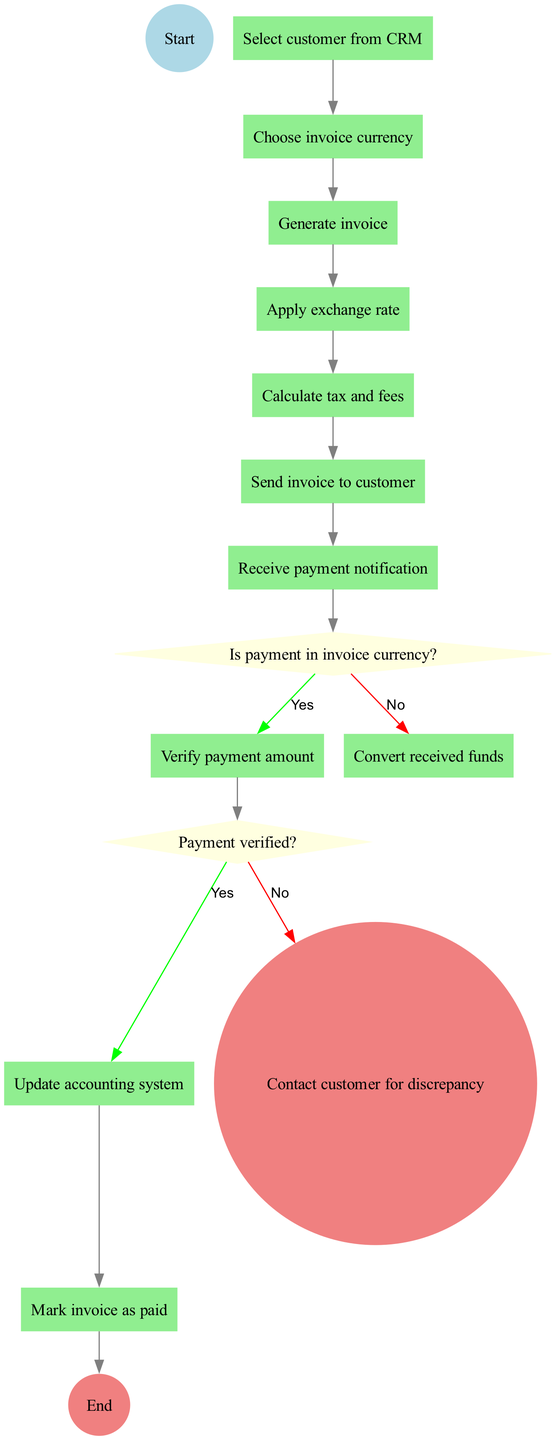What is the initial node in the diagram? The initial node is explicitly labeled as "Start". This is the first point in the flow of the activity diagram where the process begins.
Answer: Start How many activities are present in the diagram? By counting the listed activities in the provided data, we have a total of 11 distinct activities that represent various steps in the invoice generation and payment processing flow.
Answer: 11 What is the final node of the diagram? The final node is clearly stated as "End". This indicates the conclusion of the process flow represented in the activity diagram.
Answer: End What are the two outcomes of the decision "Is payment in invoice currency?" Based on the diagram structure, this decision leads to two branches: "Verify payment amount" if the answer is yes, and "Convert received funds" if the answer is no.
Answer: Verify payment amount, Convert received funds Which activity occurs immediately after "Send invoice to customer"? The activity that follows "Send invoice to customer" in the flow is "Receive payment notification". This is the next step after the invoice has been sent out.
Answer: Receive payment notification What happens if the payment is not verified? If the payment is not verified, the subsequent step, as indicated, is to "Contact customer for discrepancy". This highlights the action taken when there is an issue with verifying the payment.
Answer: Contact customer for discrepancy What is the relationship between "Verify payment amount" and "Payment verified?" "Verify payment amount" leads directly to the decision node "Payment verified?". This indicates that payment verification is a prerequisite to making a decision on whether the payment matches the expected amount.
Answer: Leads to decision node What color represents activity nodes in the diagram? Activity nodes in the diagram are represented by green, as indicated by the node styling described in the code. This color coding helps to differentiate them from other node types such as decision nodes and start/end nodes.
Answer: Light green What action occurs before updating the accounting system? Before updating the accounting system, the diagram specifies that "Payment verified?" must occur, leading to the action of "Update accounting system" if the payment verification is successful.
Answer: Verify payment amount 